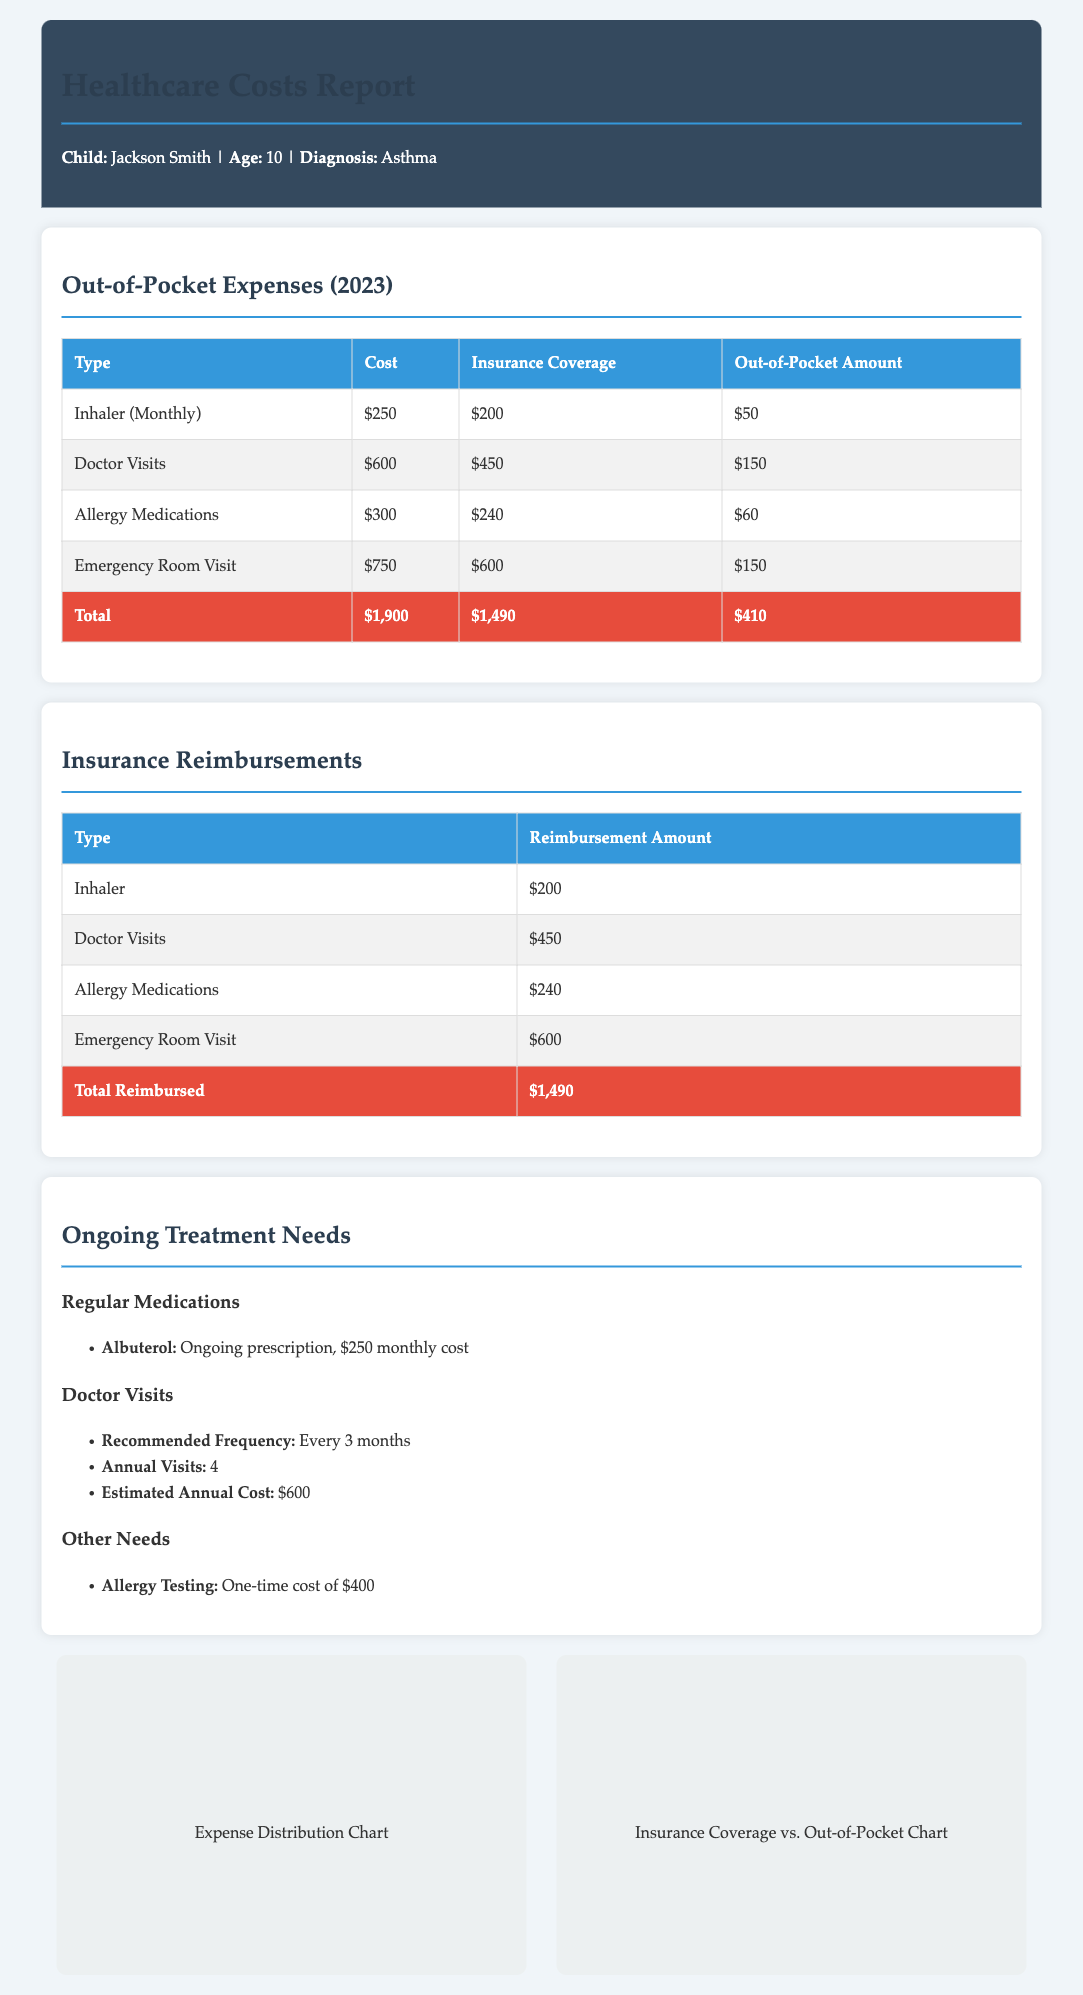What is the total out-of-pocket amount for 2023? The total out-of-pocket amount is found in the out-of-pocket expenses table, which sums to $410.
Answer: $410 How much was reimbursed for the emergency room visit? The reimbursement amount for the emergency room visit is detailed in the insurance reimbursements table, which shows $600.
Answer: $600 What is the monthly cost of Albuterol? The ongoing treatment needs section specifies the monthly cost of Albuterol as $250.
Answer: $250 How many doctor visits are recommended annually? The ongoing treatment needs section indicates that the recommended frequency of doctor visits is every 3 months, totaling 4 visits per year.
Answer: 4 What was the total reimbursement amount? The total reimbursement amount can be found in the insurance reimbursements table, which totals $1,490.
Answer: $1,490 What are the allergy testing costs? Allergy testing is listed under other needs, with a one-time cost of $400.
Answer: $400 Which medication has the highest out-of-pocket amount? The out-of-pocket expenses table shows that the inhaler has the highest out-of-pocket amount of $50.
Answer: Inhaler How often are doctor visits recommended? The ongoing treatment needs section specifies the recommended frequency for doctor visits is every 3 months.
Answer: Every 3 months What is the total cost for allergy medications? The total cost for allergy medications from the out-of-pocket expenses table is $300.
Answer: $300 